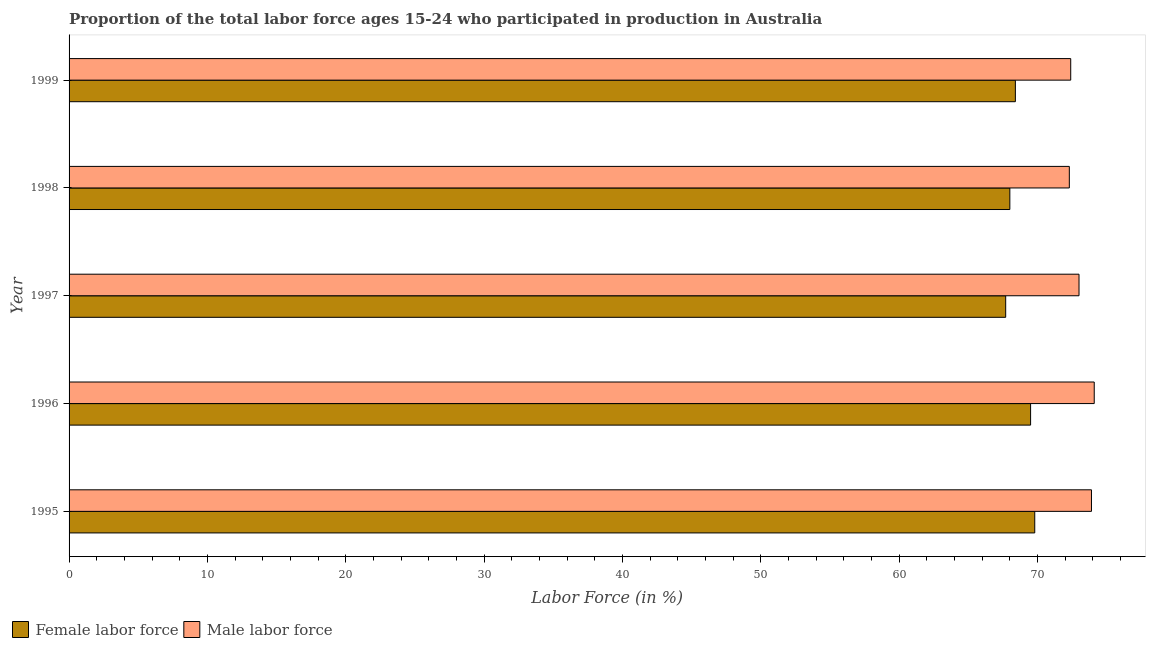How many groups of bars are there?
Offer a terse response. 5. How many bars are there on the 2nd tick from the top?
Ensure brevity in your answer.  2. What is the percentage of male labour force in 1995?
Give a very brief answer. 73.9. Across all years, what is the maximum percentage of female labor force?
Ensure brevity in your answer.  69.8. Across all years, what is the minimum percentage of female labor force?
Your answer should be compact. 67.7. In which year was the percentage of female labor force maximum?
Provide a succinct answer. 1995. What is the total percentage of male labour force in the graph?
Your answer should be compact. 365.7. What is the difference between the percentage of female labor force in 1996 and that in 1997?
Provide a succinct answer. 1.8. What is the difference between the percentage of female labor force in 1998 and the percentage of male labour force in 1999?
Make the answer very short. -4.4. What is the average percentage of female labor force per year?
Keep it short and to the point. 68.68. In how many years, is the percentage of female labor force greater than 24 %?
Provide a succinct answer. 5. What is the ratio of the percentage of male labour force in 1996 to that in 1997?
Your answer should be very brief. 1.01. Is the percentage of female labor force in 1997 less than that in 1998?
Keep it short and to the point. Yes. What is the difference between the highest and the second highest percentage of male labour force?
Ensure brevity in your answer.  0.2. In how many years, is the percentage of male labour force greater than the average percentage of male labour force taken over all years?
Make the answer very short. 2. Is the sum of the percentage of female labor force in 1996 and 1999 greater than the maximum percentage of male labour force across all years?
Offer a terse response. Yes. What does the 2nd bar from the top in 1996 represents?
Ensure brevity in your answer.  Female labor force. What does the 1st bar from the bottom in 1998 represents?
Give a very brief answer. Female labor force. How many bars are there?
Provide a succinct answer. 10. How many years are there in the graph?
Your response must be concise. 5. What is the difference between two consecutive major ticks on the X-axis?
Your answer should be very brief. 10. Are the values on the major ticks of X-axis written in scientific E-notation?
Ensure brevity in your answer.  No. Where does the legend appear in the graph?
Provide a short and direct response. Bottom left. How are the legend labels stacked?
Offer a terse response. Horizontal. What is the title of the graph?
Your answer should be compact. Proportion of the total labor force ages 15-24 who participated in production in Australia. Does "Quality of trade" appear as one of the legend labels in the graph?
Offer a terse response. No. What is the label or title of the Y-axis?
Keep it short and to the point. Year. What is the Labor Force (in %) of Female labor force in 1995?
Provide a short and direct response. 69.8. What is the Labor Force (in %) of Male labor force in 1995?
Keep it short and to the point. 73.9. What is the Labor Force (in %) of Female labor force in 1996?
Keep it short and to the point. 69.5. What is the Labor Force (in %) in Male labor force in 1996?
Your response must be concise. 74.1. What is the Labor Force (in %) in Female labor force in 1997?
Offer a very short reply. 67.7. What is the Labor Force (in %) of Male labor force in 1998?
Give a very brief answer. 72.3. What is the Labor Force (in %) of Female labor force in 1999?
Give a very brief answer. 68.4. What is the Labor Force (in %) in Male labor force in 1999?
Your answer should be very brief. 72.4. Across all years, what is the maximum Labor Force (in %) of Female labor force?
Give a very brief answer. 69.8. Across all years, what is the maximum Labor Force (in %) in Male labor force?
Ensure brevity in your answer.  74.1. Across all years, what is the minimum Labor Force (in %) of Female labor force?
Your response must be concise. 67.7. Across all years, what is the minimum Labor Force (in %) in Male labor force?
Provide a short and direct response. 72.3. What is the total Labor Force (in %) in Female labor force in the graph?
Keep it short and to the point. 343.4. What is the total Labor Force (in %) of Male labor force in the graph?
Provide a succinct answer. 365.7. What is the difference between the Labor Force (in %) of Female labor force in 1995 and that in 1997?
Keep it short and to the point. 2.1. What is the difference between the Labor Force (in %) in Female labor force in 1995 and that in 1998?
Make the answer very short. 1.8. What is the difference between the Labor Force (in %) of Female labor force in 1995 and that in 1999?
Ensure brevity in your answer.  1.4. What is the difference between the Labor Force (in %) of Male labor force in 1995 and that in 1999?
Make the answer very short. 1.5. What is the difference between the Labor Force (in %) in Male labor force in 1996 and that in 1997?
Your response must be concise. 1.1. What is the difference between the Labor Force (in %) in Female labor force in 1996 and that in 1998?
Make the answer very short. 1.5. What is the difference between the Labor Force (in %) of Female labor force in 1996 and that in 1999?
Give a very brief answer. 1.1. What is the difference between the Labor Force (in %) of Male labor force in 1996 and that in 1999?
Provide a succinct answer. 1.7. What is the difference between the Labor Force (in %) of Female labor force in 1997 and that in 1998?
Provide a short and direct response. -0.3. What is the difference between the Labor Force (in %) in Female labor force in 1997 and that in 1999?
Ensure brevity in your answer.  -0.7. What is the difference between the Labor Force (in %) of Female labor force in 1998 and that in 1999?
Give a very brief answer. -0.4. What is the difference between the Labor Force (in %) in Female labor force in 1995 and the Labor Force (in %) in Male labor force in 1998?
Keep it short and to the point. -2.5. What is the difference between the Labor Force (in %) of Female labor force in 1996 and the Labor Force (in %) of Male labor force in 1997?
Ensure brevity in your answer.  -3.5. What is the difference between the Labor Force (in %) of Female labor force in 1996 and the Labor Force (in %) of Male labor force in 1998?
Offer a very short reply. -2.8. What is the difference between the Labor Force (in %) of Female labor force in 1996 and the Labor Force (in %) of Male labor force in 1999?
Keep it short and to the point. -2.9. What is the difference between the Labor Force (in %) in Female labor force in 1997 and the Labor Force (in %) in Male labor force in 1998?
Your answer should be very brief. -4.6. What is the average Labor Force (in %) of Female labor force per year?
Your response must be concise. 68.68. What is the average Labor Force (in %) of Male labor force per year?
Your answer should be very brief. 73.14. In the year 1996, what is the difference between the Labor Force (in %) of Female labor force and Labor Force (in %) of Male labor force?
Provide a succinct answer. -4.6. In the year 1997, what is the difference between the Labor Force (in %) in Female labor force and Labor Force (in %) in Male labor force?
Your answer should be very brief. -5.3. In the year 1998, what is the difference between the Labor Force (in %) in Female labor force and Labor Force (in %) in Male labor force?
Offer a terse response. -4.3. In the year 1999, what is the difference between the Labor Force (in %) in Female labor force and Labor Force (in %) in Male labor force?
Provide a succinct answer. -4. What is the ratio of the Labor Force (in %) of Female labor force in 1995 to that in 1997?
Give a very brief answer. 1.03. What is the ratio of the Labor Force (in %) in Male labor force in 1995 to that in 1997?
Ensure brevity in your answer.  1.01. What is the ratio of the Labor Force (in %) of Female labor force in 1995 to that in 1998?
Ensure brevity in your answer.  1.03. What is the ratio of the Labor Force (in %) in Male labor force in 1995 to that in 1998?
Your answer should be compact. 1.02. What is the ratio of the Labor Force (in %) in Female labor force in 1995 to that in 1999?
Offer a very short reply. 1.02. What is the ratio of the Labor Force (in %) of Male labor force in 1995 to that in 1999?
Keep it short and to the point. 1.02. What is the ratio of the Labor Force (in %) in Female labor force in 1996 to that in 1997?
Offer a terse response. 1.03. What is the ratio of the Labor Force (in %) of Male labor force in 1996 to that in 1997?
Provide a short and direct response. 1.02. What is the ratio of the Labor Force (in %) in Female labor force in 1996 to that in 1998?
Provide a succinct answer. 1.02. What is the ratio of the Labor Force (in %) in Male labor force in 1996 to that in 1998?
Provide a succinct answer. 1.02. What is the ratio of the Labor Force (in %) of Female labor force in 1996 to that in 1999?
Give a very brief answer. 1.02. What is the ratio of the Labor Force (in %) of Male labor force in 1996 to that in 1999?
Provide a short and direct response. 1.02. What is the ratio of the Labor Force (in %) of Male labor force in 1997 to that in 1998?
Provide a short and direct response. 1.01. What is the ratio of the Labor Force (in %) in Female labor force in 1997 to that in 1999?
Make the answer very short. 0.99. What is the ratio of the Labor Force (in %) in Male labor force in 1997 to that in 1999?
Give a very brief answer. 1.01. What is the ratio of the Labor Force (in %) in Female labor force in 1998 to that in 1999?
Ensure brevity in your answer.  0.99. What is the difference between the highest and the lowest Labor Force (in %) of Female labor force?
Your answer should be very brief. 2.1. What is the difference between the highest and the lowest Labor Force (in %) in Male labor force?
Give a very brief answer. 1.8. 